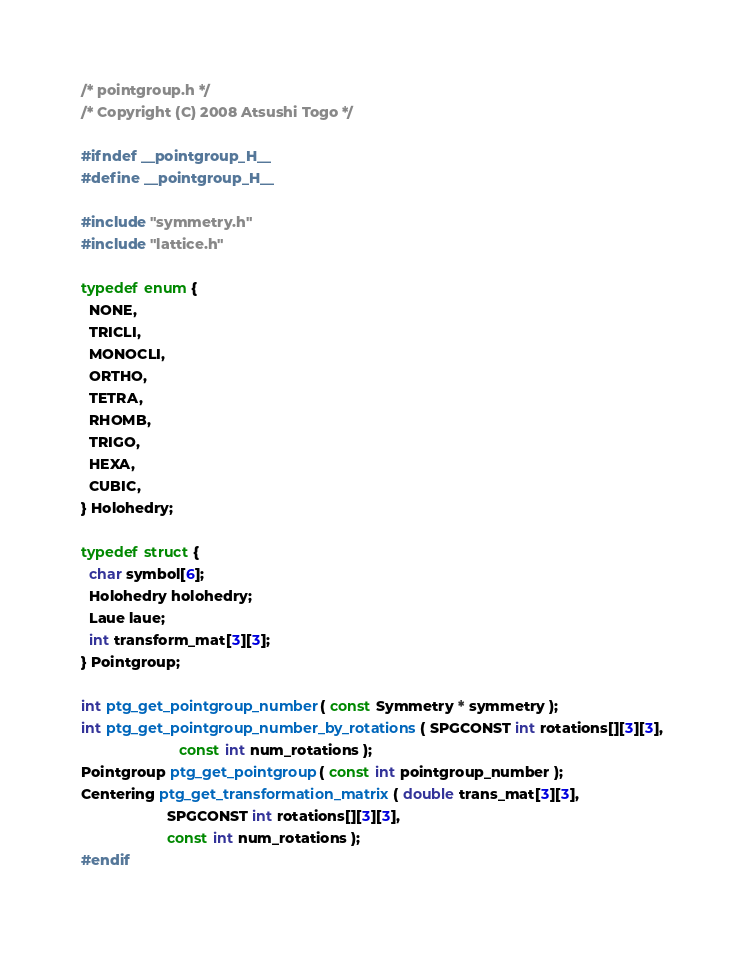<code> <loc_0><loc_0><loc_500><loc_500><_C_>/* pointgroup.h */
/* Copyright (C) 2008 Atsushi Togo */

#ifndef __pointgroup_H__
#define __pointgroup_H__

#include "symmetry.h"
#include "lattice.h"

typedef enum {
  NONE,
  TRICLI,
  MONOCLI,
  ORTHO,
  TETRA,
  RHOMB,
  TRIGO,
  HEXA,
  CUBIC,
} Holohedry;

typedef struct {
  char symbol[6];
  Holohedry holohedry;
  Laue laue;
  int transform_mat[3][3];
} Pointgroup;

int ptg_get_pointgroup_number( const Symmetry * symmetry );
int ptg_get_pointgroup_number_by_rotations( SPGCONST int rotations[][3][3],
					    const int num_rotations );
Pointgroup ptg_get_pointgroup( const int pointgroup_number );
Centering ptg_get_transformation_matrix( double trans_mat[3][3],
					 SPGCONST int rotations[][3][3],
					 const int num_rotations );
#endif
</code> 